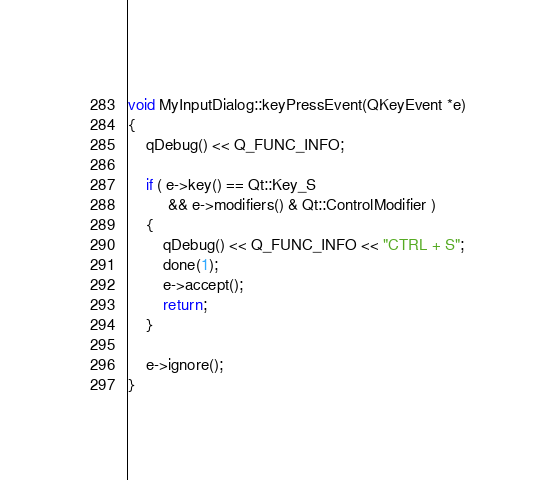Convert code to text. <code><loc_0><loc_0><loc_500><loc_500><_C++_>
void MyInputDialog::keyPressEvent(QKeyEvent *e)
{
    qDebug() << Q_FUNC_INFO;

    if ( e->key() == Qt::Key_S
         && e->modifiers() & Qt::ControlModifier )
    {
        qDebug() << Q_FUNC_INFO << "CTRL + S";
        done(1);
        e->accept();
        return;
    }

    e->ignore();
}
</code> 